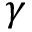<formula> <loc_0><loc_0><loc_500><loc_500>\gamma</formula> 